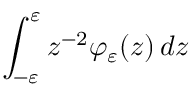<formula> <loc_0><loc_0><loc_500><loc_500>\int _ { - \varepsilon } ^ { \varepsilon } z ^ { - 2 } \varphi _ { \varepsilon } ( z ) \, { d { z } }</formula> 